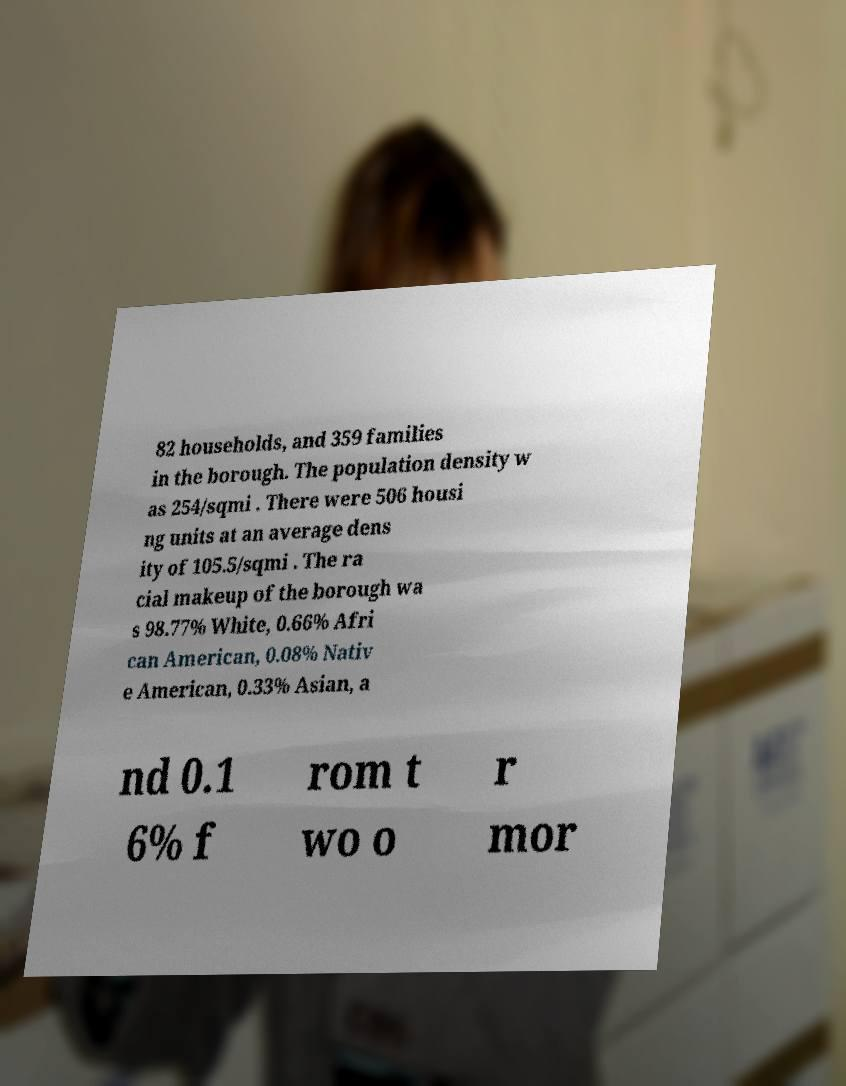What messages or text are displayed in this image? I need them in a readable, typed format. 82 households, and 359 families in the borough. The population density w as 254/sqmi . There were 506 housi ng units at an average dens ity of 105.5/sqmi . The ra cial makeup of the borough wa s 98.77% White, 0.66% Afri can American, 0.08% Nativ e American, 0.33% Asian, a nd 0.1 6% f rom t wo o r mor 